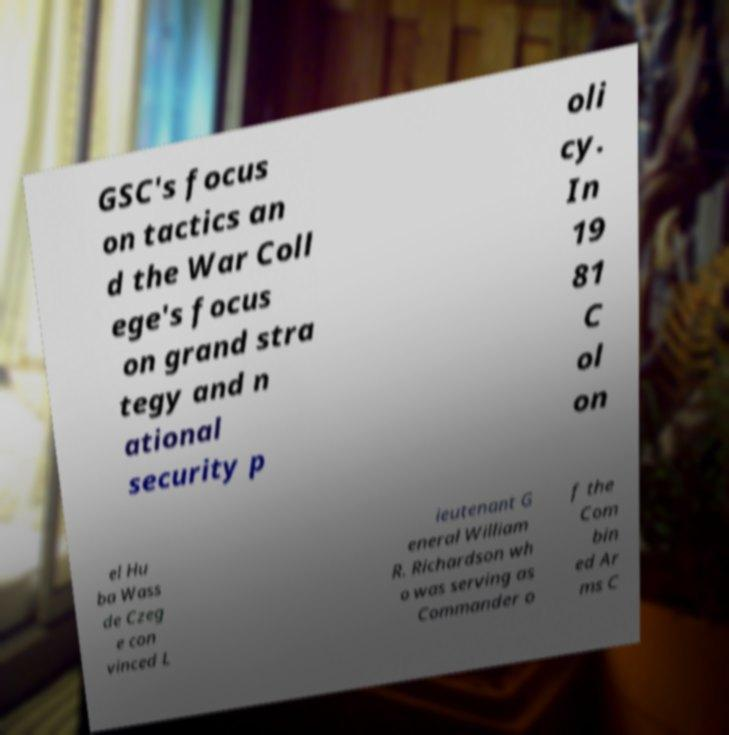Could you assist in decoding the text presented in this image and type it out clearly? GSC's focus on tactics an d the War Coll ege's focus on grand stra tegy and n ational security p oli cy. In 19 81 C ol on el Hu ba Wass de Czeg e con vinced L ieutenant G eneral William R. Richardson wh o was serving as Commander o f the Com bin ed Ar ms C 